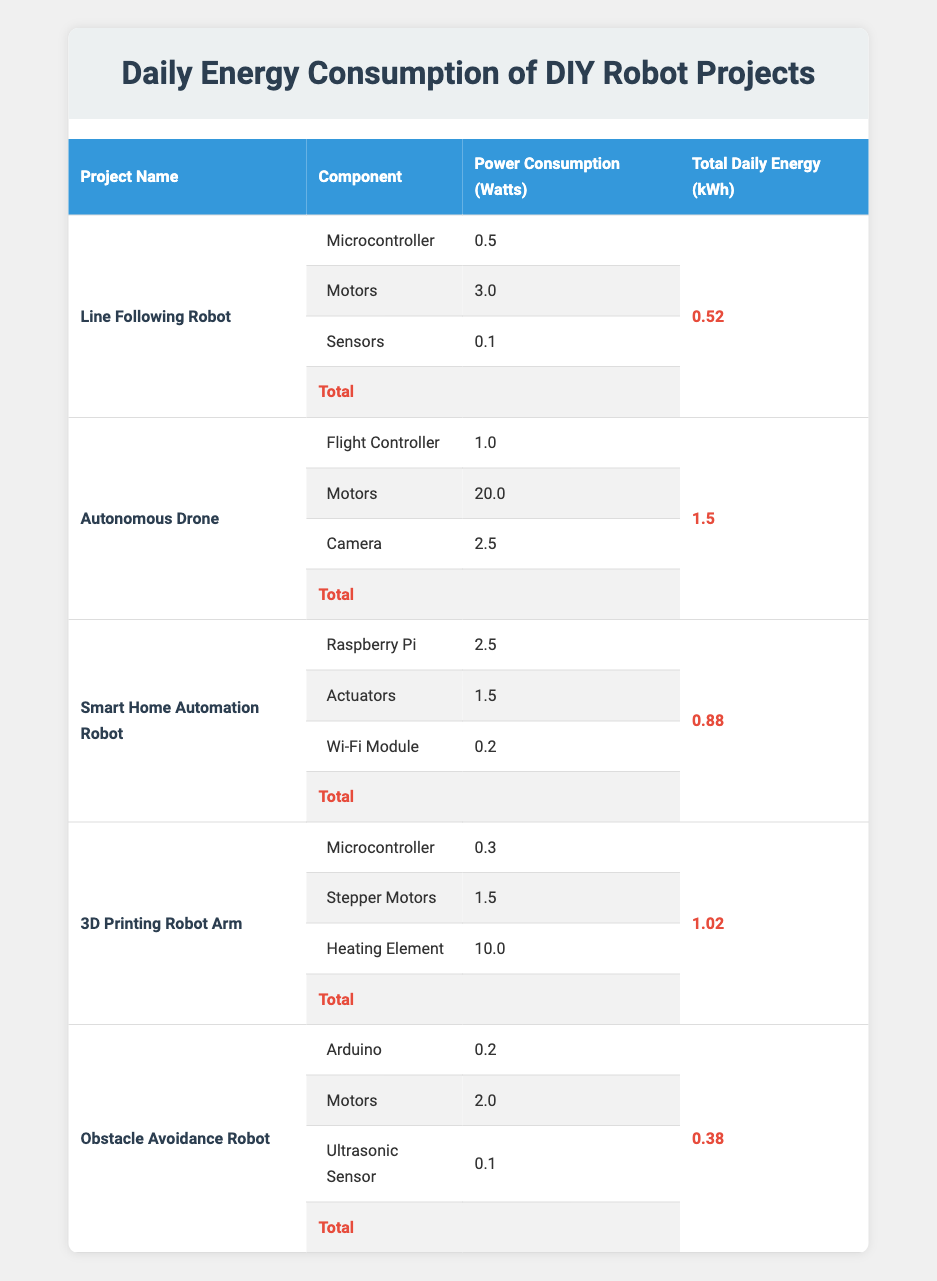What is the total daily energy consumption of the Autonomous Drone? The total daily energy consumption for the Autonomous Drone is given directly in the table under the "Total Daily Energy (kWh)" column, which states "1.5" kWh.
Answer: 1.5 Which project has the highest total daily energy consumption? By checking the "Total Daily Energy (kWh)" column, the values are: 0.52, 1.5, 0.88, 1.02, and 0.38. The highest among these is 1.5 kWh for the Autonomous Drone.
Answer: Autonomous Drone How much energy does the Motors component of the 3D Printing Robot Arm consume daily? The power consumption for the Motors in the 3D Printing Robot Arm is listed in the table under the "Power Consumption (Watts)" column, which states "1.5" watts.
Answer: 1.5 If you combine the total daily energy consumption of the Line Following Robot and the Obstacle Avoidance Robot, what will it be? The total daily energy consumption for the Line Following Robot is 0.52 kWh and for the Obstacle Avoidance Robot is 0.38 kWh. Adding these gives 0.52 + 0.38 = 0.90 kWh.
Answer: 0.90 Does the Smart Home Automation Robot consume less daily energy than the Obstacle Avoidance Robot? Comparing the total daily energy consumptions, the Smart Home Automation Robot uses 0.88 kWh, while the Obstacle Avoidance Robot uses 0.38 kWh. Since 0.88 > 0.38, the statement is false.
Answer: No What is the average daily energy consumption for all the projects combined? The total daily energy consumptions are: 0.52, 1.5, 0.88, 1.02, and 0.38 kWh. To find the average, sum these values: 0.52 + 1.5 + 0.88 + 1.02 + 0.38 = 4.30 kWh. Then, divide by the number of projects (5): 4.30 / 5 = 0.86 kWh.
Answer: 0.86 Which component of the Autonomous Drone has the highest power consumption? The components listed for the Autonomous Drone are: Flight Controller (1.0 watts), Motors (20.0 watts), and Camera (2.5 watts). Comparing these, the Motors consume the most at 20.0 watts.
Answer: Motors Is the power consumption of the Sensors in the Line Following Robot greater than that of the Ultrasonic Sensor in the Obstacle Avoidance Robot? The Sensors in the Line Following Robot consume 0.1 watts while the Ultrasonic Sensor in the Obstacle Avoidance Robot also consumes 0.1 watts. Since both are equal, the statement is false.
Answer: No What is the total power consumption of components for the 3D Printing Robot Arm? The components are: Microcontroller (0.3), Stepper Motors (1.5), and Heating Element (10.0) watts. By adding them together: 0.3 + 1.5 + 10.0 = 11.8 watts.
Answer: 11.8 